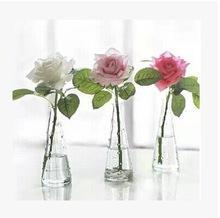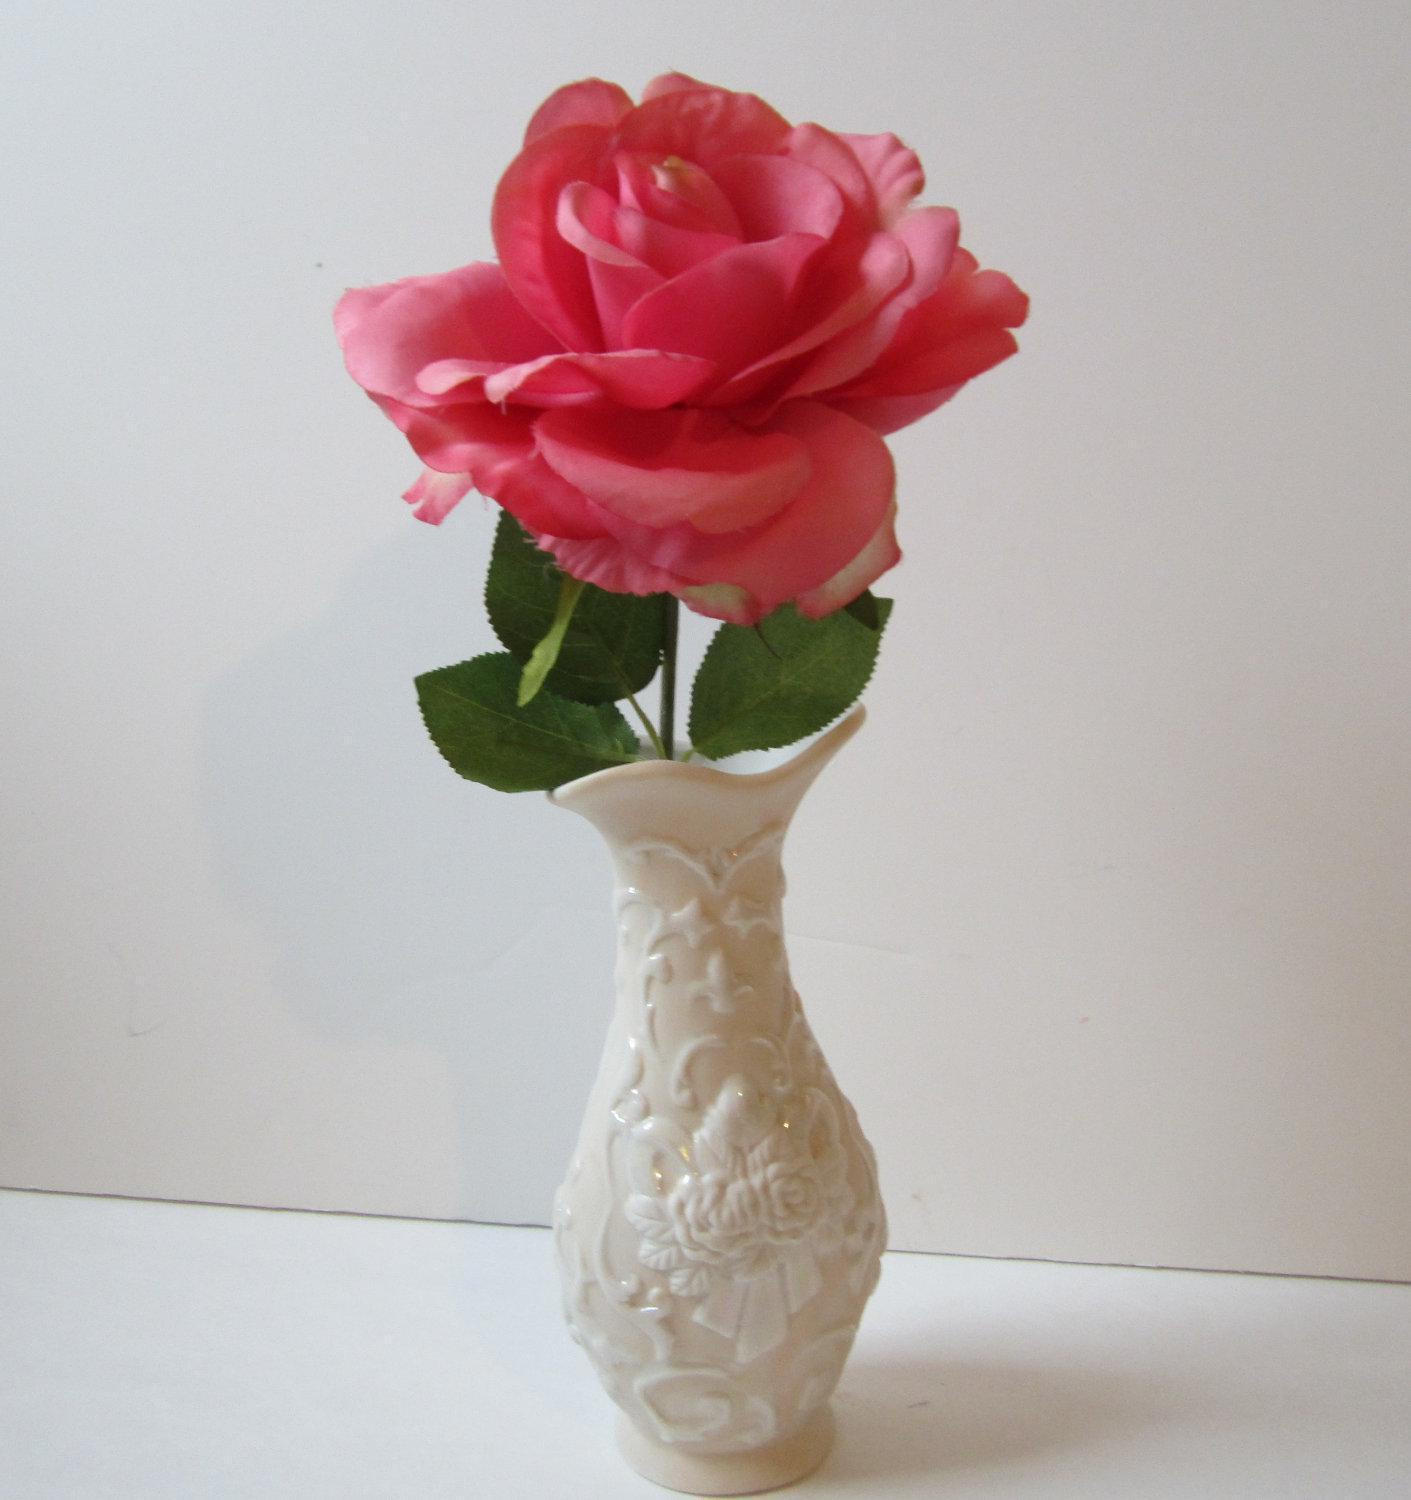The first image is the image on the left, the second image is the image on the right. Examine the images to the left and right. Is the description "There are exactly two clear glass vases." accurate? Answer yes or no. No. The first image is the image on the left, the second image is the image on the right. Examine the images to the left and right. Is the description "There are 2 vases." accurate? Answer yes or no. No. 